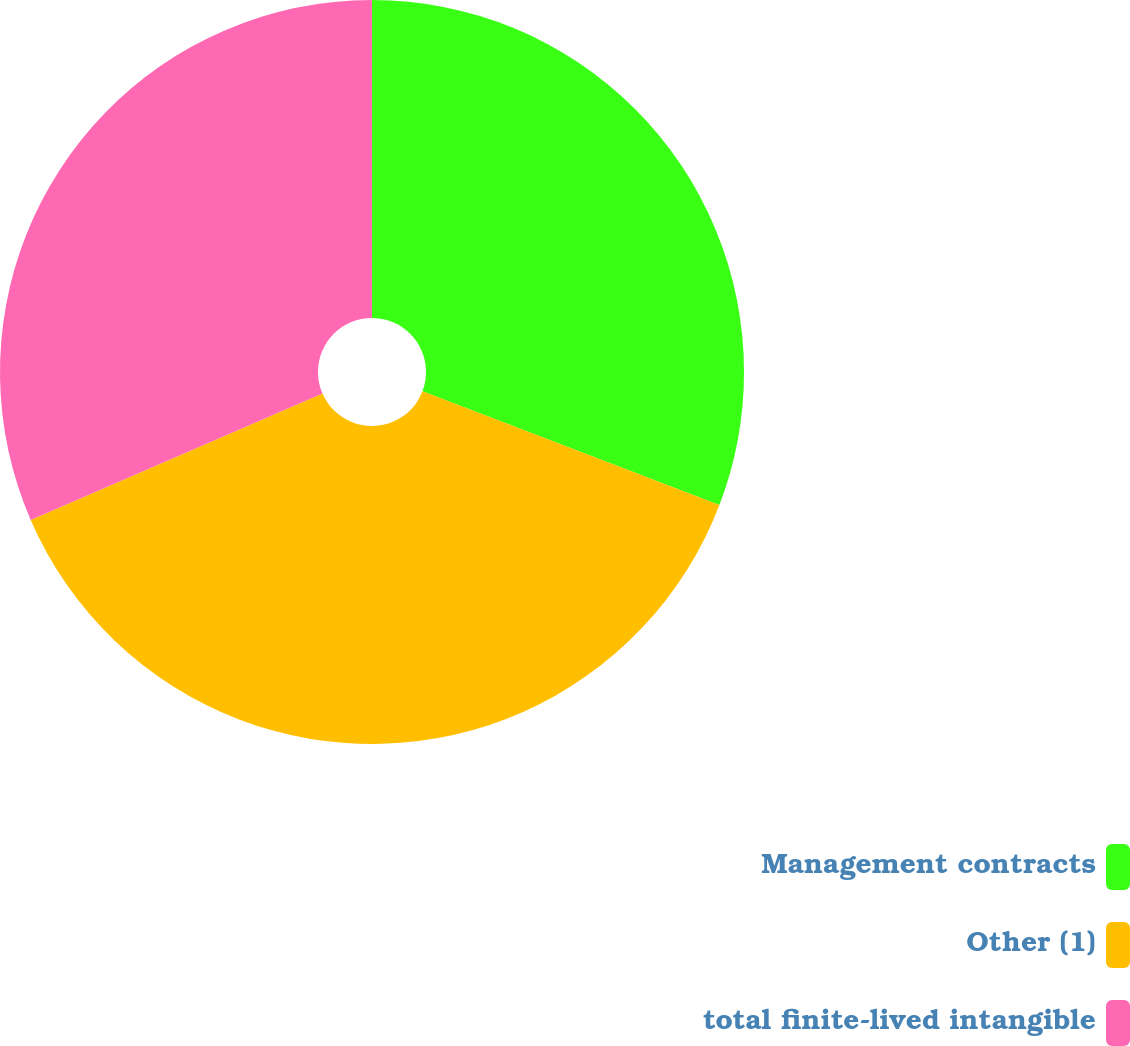<chart> <loc_0><loc_0><loc_500><loc_500><pie_chart><fcel>Management contracts<fcel>Other (1)<fcel>total finite-lived intangible<nl><fcel>30.82%<fcel>37.67%<fcel>31.51%<nl></chart> 